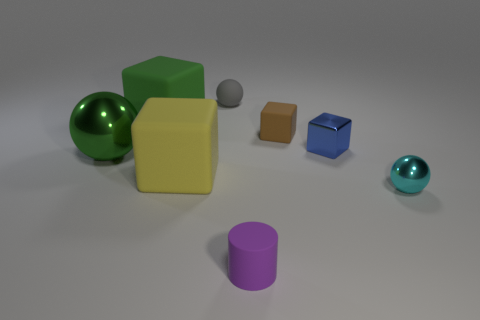Subtract all green matte cubes. How many cubes are left? 3 Subtract all cyan spheres. How many spheres are left? 2 Add 2 small gray things. How many objects exist? 10 Subtract all balls. How many objects are left? 5 Subtract all small matte cubes. Subtract all big blue metal things. How many objects are left? 7 Add 4 small blue metal blocks. How many small blue metal blocks are left? 5 Add 1 small gray spheres. How many small gray spheres exist? 2 Subtract 0 blue cylinders. How many objects are left? 8 Subtract all gray spheres. Subtract all red cylinders. How many spheres are left? 2 